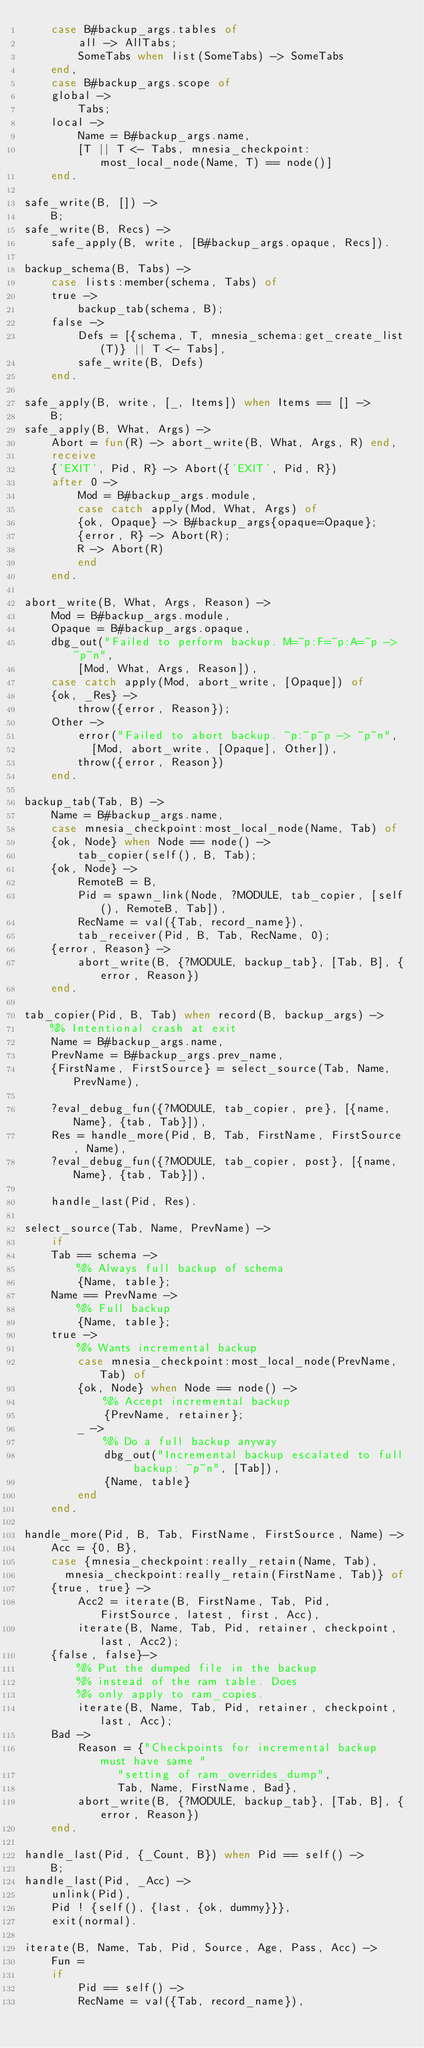Convert code to text. <code><loc_0><loc_0><loc_500><loc_500><_Erlang_>	case B#backup_args.tables of
	    all -> AllTabs;
	    SomeTabs when list(SomeTabs) -> SomeTabs
	end,
    case B#backup_args.scope of
	global ->
	    Tabs;
	local ->
	    Name = B#backup_args.name,
	    [T || T <- Tabs, mnesia_checkpoint:most_local_node(Name, T) == node()]
    end.

safe_write(B, []) ->
    B;
safe_write(B, Recs) ->	
    safe_apply(B, write, [B#backup_args.opaque, Recs]).

backup_schema(B, Tabs) ->
    case lists:member(schema, Tabs) of
	true ->
	    backup_tab(schema, B);
	false ->
	    Defs = [{schema, T, mnesia_schema:get_create_list(T)} || T <- Tabs],
	    safe_write(B, Defs)
    end.

safe_apply(B, write, [_, Items]) when Items == [] ->
    B;
safe_apply(B, What, Args) ->
    Abort = fun(R) -> abort_write(B, What, Args, R) end,
    receive
	{'EXIT', Pid, R} -> Abort({'EXIT', Pid, R})
    after 0 ->
	    Mod = B#backup_args.module,
	    case catch apply(Mod, What, Args) of
		{ok, Opaque} -> B#backup_args{opaque=Opaque};
		{error, R} -> Abort(R);
		R -> Abort(R)
	    end
    end.

abort_write(B, What, Args, Reason) ->
    Mod = B#backup_args.module,
    Opaque = B#backup_args.opaque,
    dbg_out("Failed to perform backup. M=~p:F=~p:A=~p -> ~p~n",
	    [Mod, What, Args, Reason]),
    case catch apply(Mod, abort_write, [Opaque]) of
	{ok, _Res} ->
	    throw({error, Reason});
	Other ->
	    error("Failed to abort backup. ~p:~p~p -> ~p~n",
		  [Mod, abort_write, [Opaque], Other]),
	    throw({error, Reason})
    end.
	
backup_tab(Tab, B) ->
    Name = B#backup_args.name,
    case mnesia_checkpoint:most_local_node(Name, Tab) of
	{ok, Node} when Node == node() ->
	    tab_copier(self(), B, Tab);
	{ok, Node} ->
	    RemoteB = B,
	    Pid = spawn_link(Node, ?MODULE, tab_copier, [self(), RemoteB, Tab]),
	    RecName = val({Tab, record_name}),
	    tab_receiver(Pid, B, Tab, RecName, 0);
	{error, Reason} ->
	    abort_write(B, {?MODULE, backup_tab}, [Tab, B], {error, Reason})
    end.
    
tab_copier(Pid, B, Tab) when record(B, backup_args) ->
    %% Intentional crash at exit
    Name = B#backup_args.name,
    PrevName = B#backup_args.prev_name,
    {FirstName, FirstSource} = select_source(Tab, Name, PrevName),

    ?eval_debug_fun({?MODULE, tab_copier, pre}, [{name, Name}, {tab, Tab}]),
    Res = handle_more(Pid, B, Tab, FirstName, FirstSource, Name),
    ?eval_debug_fun({?MODULE, tab_copier, post}, [{name, Name}, {tab, Tab}]),

    handle_last(Pid, Res).

select_source(Tab, Name, PrevName) ->
    if
	Tab == schema ->
	    %% Always full backup of schema
	    {Name, table};
	Name == PrevName ->
	    %% Full backup
	    {Name, table};
	true ->
	    %% Wants incremental backup
	    case mnesia_checkpoint:most_local_node(PrevName, Tab) of
		{ok, Node} when Node == node() ->
		    %% Accept incremental backup
		    {PrevName, retainer};
		_ ->
		    %% Do a full backup anyway
		    dbg_out("Incremental backup escalated to full backup: ~p~n", [Tab]),
		    {Name, table}
	    end
    end.

handle_more(Pid, B, Tab, FirstName, FirstSource, Name) ->
    Acc = {0, B},
    case {mnesia_checkpoint:really_retain(Name, Tab),
	  mnesia_checkpoint:really_retain(FirstName, Tab)} of
	{true, true} ->
	    Acc2 = iterate(B, FirstName, Tab, Pid, FirstSource, latest, first, Acc),
	    iterate(B, Name, Tab, Pid, retainer, checkpoint, last, Acc2);
	{false, false}->
	    %% Put the dumped file in the backup
	    %% instead of the ram table. Does
	    %% only apply to ram_copies.
	    iterate(B, Name, Tab, Pid, retainer, checkpoint, last, Acc);
	Bad ->
	    Reason = {"Checkpoints for incremental backup must have same "
		      "setting of ram_overrides_dump",
		      Tab, Name, FirstName, Bad},
	    abort_write(B, {?MODULE, backup_tab}, [Tab, B], {error, Reason})
    end.

handle_last(Pid, {_Count, B}) when Pid == self() ->
    B;
handle_last(Pid, _Acc) ->
    unlink(Pid),
    Pid ! {self(), {last, {ok, dummy}}},
    exit(normal).

iterate(B, Name, Tab, Pid, Source, Age, Pass, Acc) ->
    Fun = 
	if
	    Pid == self() ->
		RecName = val({Tab, record_name}),</code> 